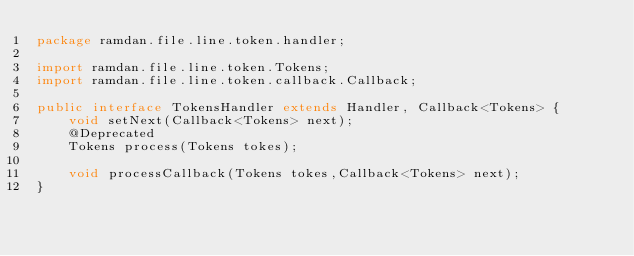Convert code to text. <code><loc_0><loc_0><loc_500><loc_500><_Java_>package ramdan.file.line.token.handler;

import ramdan.file.line.token.Tokens;
import ramdan.file.line.token.callback.Callback;

public interface TokensHandler extends Handler, Callback<Tokens> {
    void setNext(Callback<Tokens> next);
    @Deprecated
    Tokens process(Tokens tokes);

    void processCallback(Tokens tokes,Callback<Tokens> next);
}
</code> 